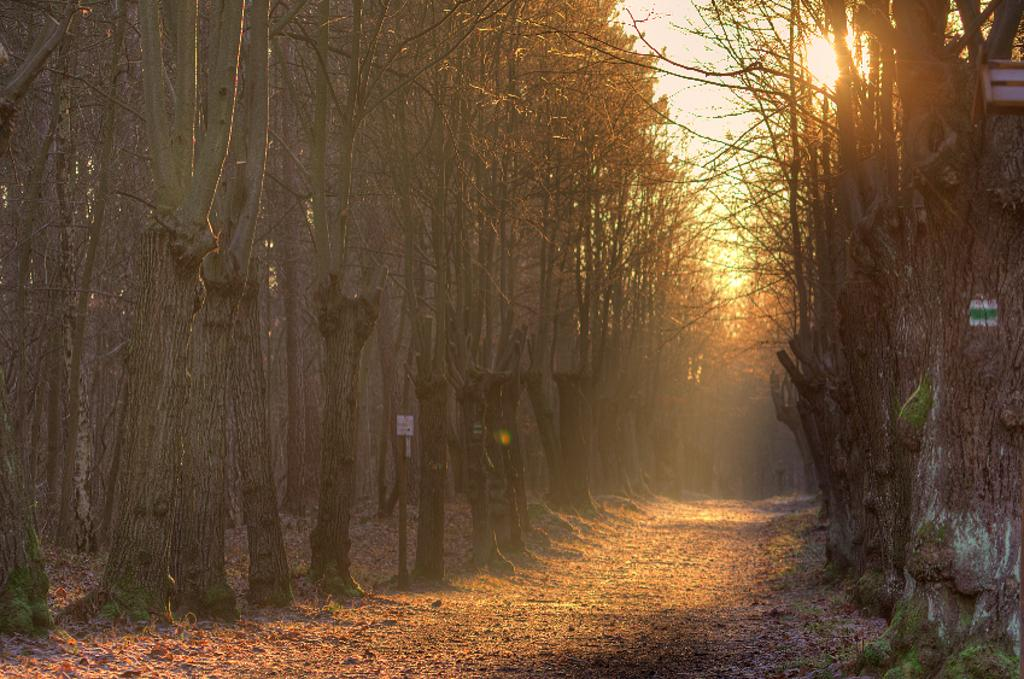What type of vegetation can be seen in the image? There are trees in the image. What can be found on the ground in the image? There is a path in the image. What is visible in the background of the image? The sky is visible in the background of the image. Can the sun be seen in the image? Yes, the sun is observable in the sky. What type of clover is growing on the path in the image? There is no clover present in the image; it only features trees, a path, and the sky. What kind of apparatus is being used by the trees in the image? There is no apparatus present in the image; the trees are simply standing in the image. 